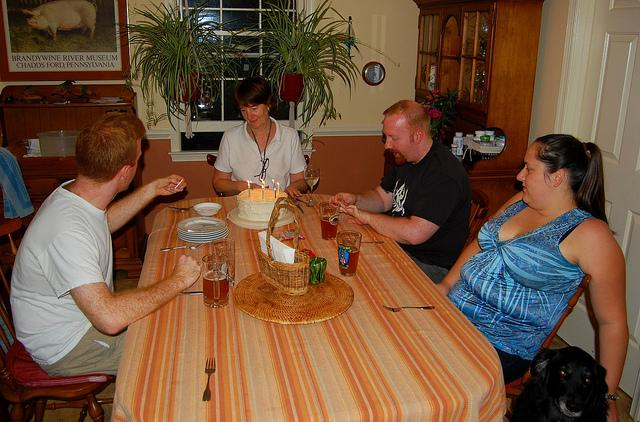Why are there candles in the cake in front of the woman? birthday 